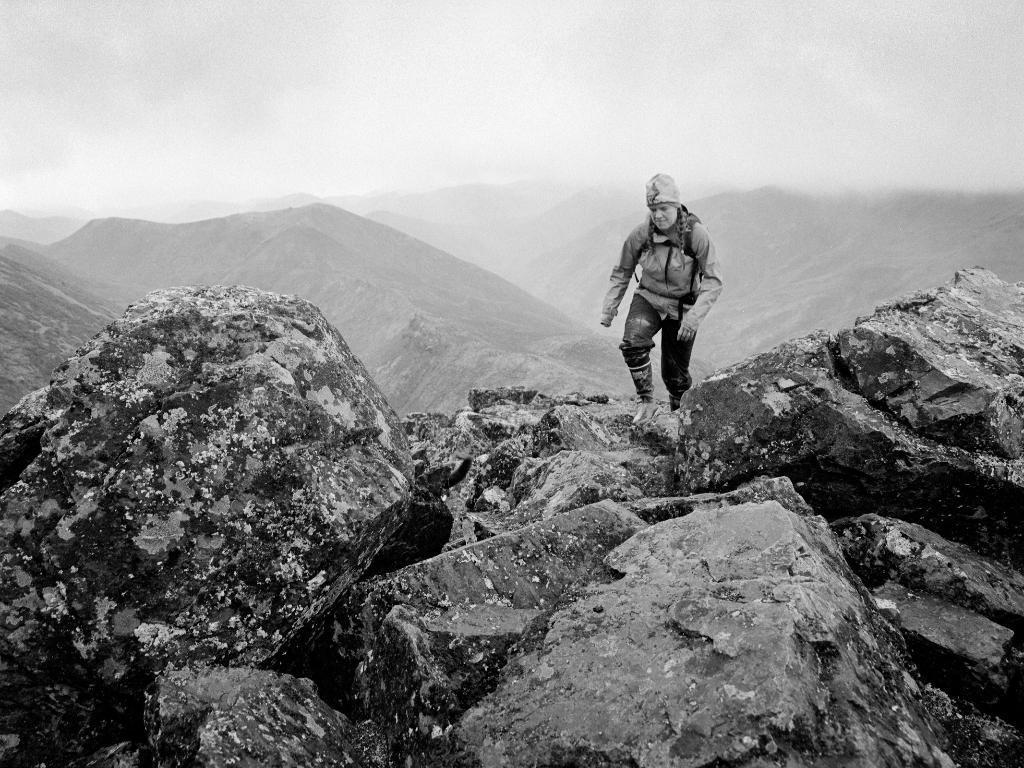Please provide a concise description of this image. In the picture we can see rocks on it, we can see a man standing, he is with jacket and cap and in the background we can see some hills and sky with clouds. 